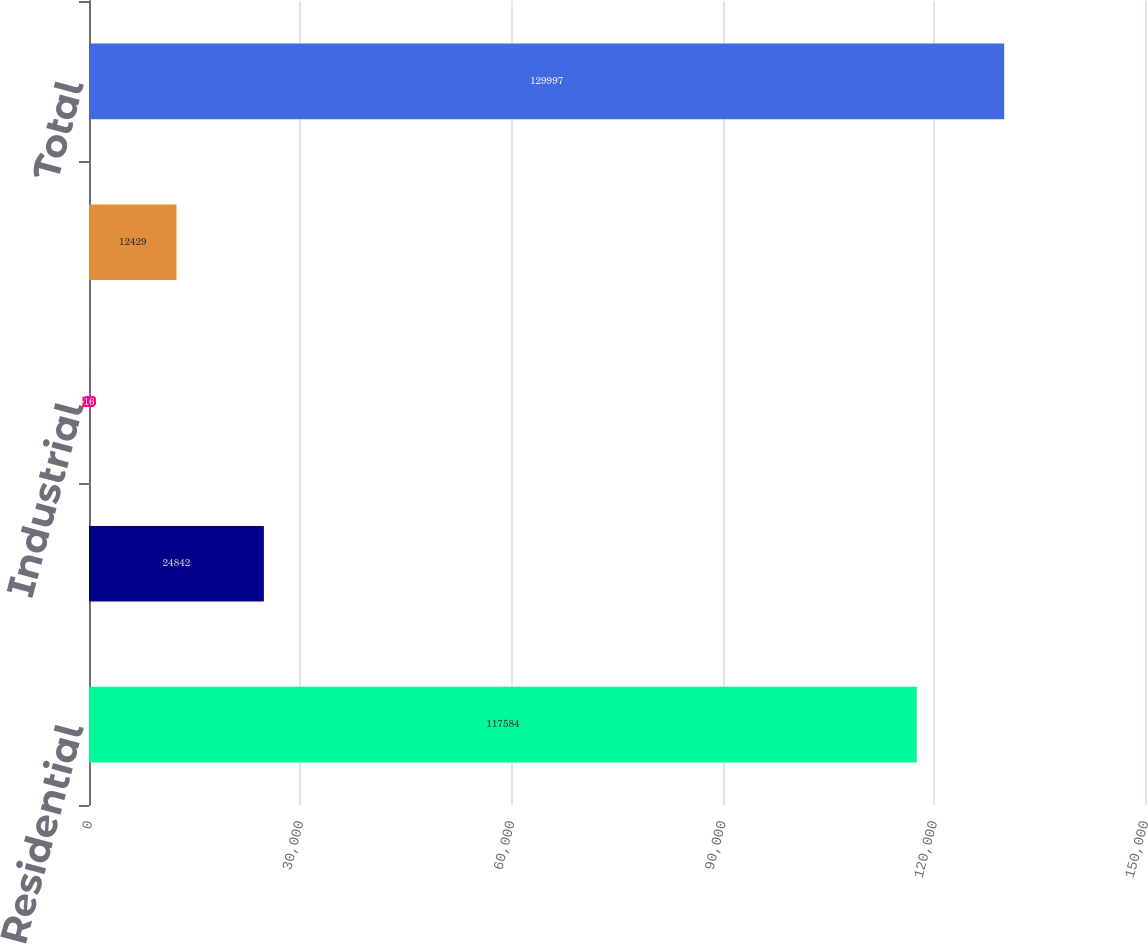Convert chart to OTSL. <chart><loc_0><loc_0><loc_500><loc_500><bar_chart><fcel>Residential<fcel>Commercial<fcel>Industrial<fcel>Public & other<fcel>Total<nl><fcel>117584<fcel>24842<fcel>16<fcel>12429<fcel>129997<nl></chart> 